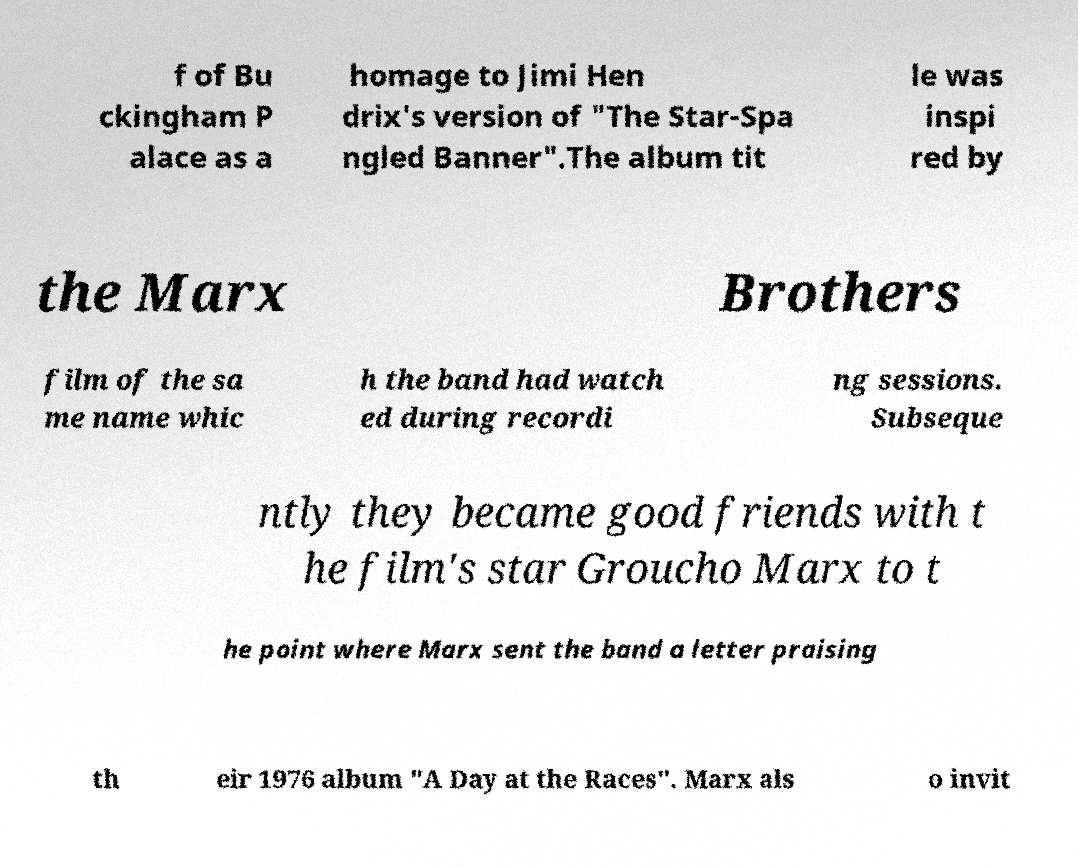For documentation purposes, I need the text within this image transcribed. Could you provide that? f of Bu ckingham P alace as a homage to Jimi Hen drix's version of "The Star-Spa ngled Banner".The album tit le was inspi red by the Marx Brothers film of the sa me name whic h the band had watch ed during recordi ng sessions. Subseque ntly they became good friends with t he film's star Groucho Marx to t he point where Marx sent the band a letter praising th eir 1976 album "A Day at the Races". Marx als o invit 